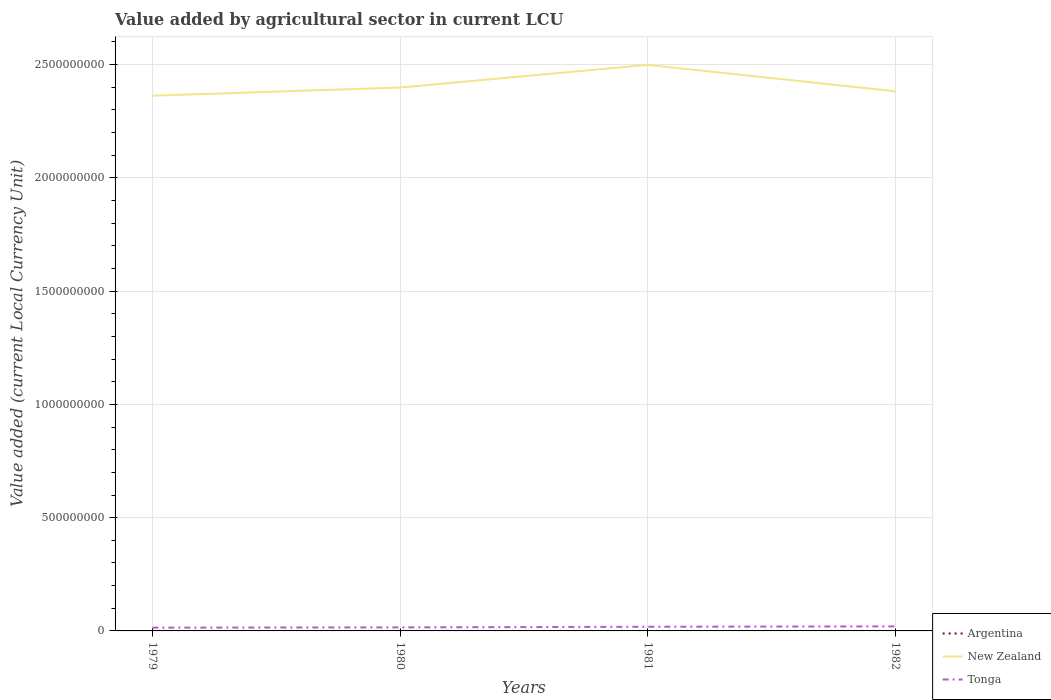How many different coloured lines are there?
Ensure brevity in your answer.  3. Does the line corresponding to Tonga intersect with the line corresponding to New Zealand?
Your answer should be very brief. No. Is the number of lines equal to the number of legend labels?
Offer a terse response. Yes. Across all years, what is the maximum value added by agricultural sector in New Zealand?
Offer a very short reply. 2.36e+09. In which year was the value added by agricultural sector in New Zealand maximum?
Give a very brief answer. 1979. What is the total value added by agricultural sector in New Zealand in the graph?
Offer a terse response. -1.00e+08. What is the difference between the highest and the second highest value added by agricultural sector in Argentina?
Give a very brief answer. 1946.37. What is the difference between the highest and the lowest value added by agricultural sector in Tonga?
Offer a very short reply. 2. How many lines are there?
Ensure brevity in your answer.  3. What is the difference between two consecutive major ticks on the Y-axis?
Ensure brevity in your answer.  5.00e+08. Are the values on the major ticks of Y-axis written in scientific E-notation?
Give a very brief answer. No. How many legend labels are there?
Ensure brevity in your answer.  3. How are the legend labels stacked?
Your answer should be compact. Vertical. What is the title of the graph?
Your response must be concise. Value added by agricultural sector in current LCU. What is the label or title of the X-axis?
Your answer should be very brief. Years. What is the label or title of the Y-axis?
Keep it short and to the point. Value added (current Local Currency Unit). What is the Value added (current Local Currency Unit) of Argentina in 1979?
Offer a very short reply. 150.63. What is the Value added (current Local Currency Unit) in New Zealand in 1979?
Make the answer very short. 2.36e+09. What is the Value added (current Local Currency Unit) of Tonga in 1979?
Keep it short and to the point. 1.45e+07. What is the Value added (current Local Currency Unit) of Argentina in 1980?
Your response must be concise. 244. What is the Value added (current Local Currency Unit) of New Zealand in 1980?
Make the answer very short. 2.40e+09. What is the Value added (current Local Currency Unit) in Tonga in 1980?
Give a very brief answer. 1.56e+07. What is the Value added (current Local Currency Unit) of Argentina in 1981?
Provide a short and direct response. 484. What is the Value added (current Local Currency Unit) in New Zealand in 1981?
Make the answer very short. 2.50e+09. What is the Value added (current Local Currency Unit) of Tonga in 1981?
Keep it short and to the point. 1.83e+07. What is the Value added (current Local Currency Unit) in Argentina in 1982?
Make the answer very short. 2097. What is the Value added (current Local Currency Unit) in New Zealand in 1982?
Provide a succinct answer. 2.38e+09. What is the Value added (current Local Currency Unit) in Tonga in 1982?
Provide a succinct answer. 2.00e+07. Across all years, what is the maximum Value added (current Local Currency Unit) in Argentina?
Your response must be concise. 2097. Across all years, what is the maximum Value added (current Local Currency Unit) in New Zealand?
Your answer should be very brief. 2.50e+09. Across all years, what is the maximum Value added (current Local Currency Unit) of Tonga?
Your answer should be very brief. 2.00e+07. Across all years, what is the minimum Value added (current Local Currency Unit) of Argentina?
Provide a succinct answer. 150.63. Across all years, what is the minimum Value added (current Local Currency Unit) of New Zealand?
Ensure brevity in your answer.  2.36e+09. Across all years, what is the minimum Value added (current Local Currency Unit) in Tonga?
Provide a succinct answer. 1.45e+07. What is the total Value added (current Local Currency Unit) in Argentina in the graph?
Your response must be concise. 2975.64. What is the total Value added (current Local Currency Unit) of New Zealand in the graph?
Offer a very short reply. 9.64e+09. What is the total Value added (current Local Currency Unit) of Tonga in the graph?
Offer a terse response. 6.85e+07. What is the difference between the Value added (current Local Currency Unit) of Argentina in 1979 and that in 1980?
Provide a short and direct response. -93.36. What is the difference between the Value added (current Local Currency Unit) in New Zealand in 1979 and that in 1980?
Offer a very short reply. -3.60e+07. What is the difference between the Value added (current Local Currency Unit) of Tonga in 1979 and that in 1980?
Keep it short and to the point. -1.15e+06. What is the difference between the Value added (current Local Currency Unit) in Argentina in 1979 and that in 1981?
Ensure brevity in your answer.  -333.37. What is the difference between the Value added (current Local Currency Unit) in New Zealand in 1979 and that in 1981?
Your response must be concise. -1.36e+08. What is the difference between the Value added (current Local Currency Unit) in Tonga in 1979 and that in 1981?
Ensure brevity in your answer.  -3.84e+06. What is the difference between the Value added (current Local Currency Unit) in Argentina in 1979 and that in 1982?
Offer a terse response. -1946.37. What is the difference between the Value added (current Local Currency Unit) of New Zealand in 1979 and that in 1982?
Offer a very short reply. -1.92e+07. What is the difference between the Value added (current Local Currency Unit) of Tonga in 1979 and that in 1982?
Your answer should be very brief. -5.55e+06. What is the difference between the Value added (current Local Currency Unit) of Argentina in 1980 and that in 1981?
Your answer should be very brief. -240. What is the difference between the Value added (current Local Currency Unit) of New Zealand in 1980 and that in 1981?
Make the answer very short. -1.00e+08. What is the difference between the Value added (current Local Currency Unit) of Tonga in 1980 and that in 1981?
Offer a terse response. -2.69e+06. What is the difference between the Value added (current Local Currency Unit) in Argentina in 1980 and that in 1982?
Give a very brief answer. -1853. What is the difference between the Value added (current Local Currency Unit) of New Zealand in 1980 and that in 1982?
Provide a succinct answer. 1.67e+07. What is the difference between the Value added (current Local Currency Unit) in Tonga in 1980 and that in 1982?
Your response must be concise. -4.41e+06. What is the difference between the Value added (current Local Currency Unit) in Argentina in 1981 and that in 1982?
Offer a terse response. -1613. What is the difference between the Value added (current Local Currency Unit) in New Zealand in 1981 and that in 1982?
Give a very brief answer. 1.17e+08. What is the difference between the Value added (current Local Currency Unit) of Tonga in 1981 and that in 1982?
Provide a short and direct response. -1.72e+06. What is the difference between the Value added (current Local Currency Unit) in Argentina in 1979 and the Value added (current Local Currency Unit) in New Zealand in 1980?
Your response must be concise. -2.40e+09. What is the difference between the Value added (current Local Currency Unit) in Argentina in 1979 and the Value added (current Local Currency Unit) in Tonga in 1980?
Offer a very short reply. -1.56e+07. What is the difference between the Value added (current Local Currency Unit) in New Zealand in 1979 and the Value added (current Local Currency Unit) in Tonga in 1980?
Offer a very short reply. 2.35e+09. What is the difference between the Value added (current Local Currency Unit) of Argentina in 1979 and the Value added (current Local Currency Unit) of New Zealand in 1981?
Your answer should be very brief. -2.50e+09. What is the difference between the Value added (current Local Currency Unit) in Argentina in 1979 and the Value added (current Local Currency Unit) in Tonga in 1981?
Provide a short and direct response. -1.83e+07. What is the difference between the Value added (current Local Currency Unit) in New Zealand in 1979 and the Value added (current Local Currency Unit) in Tonga in 1981?
Your answer should be compact. 2.34e+09. What is the difference between the Value added (current Local Currency Unit) of Argentina in 1979 and the Value added (current Local Currency Unit) of New Zealand in 1982?
Your answer should be very brief. -2.38e+09. What is the difference between the Value added (current Local Currency Unit) of Argentina in 1979 and the Value added (current Local Currency Unit) of Tonga in 1982?
Offer a very short reply. -2.00e+07. What is the difference between the Value added (current Local Currency Unit) in New Zealand in 1979 and the Value added (current Local Currency Unit) in Tonga in 1982?
Ensure brevity in your answer.  2.34e+09. What is the difference between the Value added (current Local Currency Unit) of Argentina in 1980 and the Value added (current Local Currency Unit) of New Zealand in 1981?
Provide a succinct answer. -2.50e+09. What is the difference between the Value added (current Local Currency Unit) of Argentina in 1980 and the Value added (current Local Currency Unit) of Tonga in 1981?
Give a very brief answer. -1.83e+07. What is the difference between the Value added (current Local Currency Unit) of New Zealand in 1980 and the Value added (current Local Currency Unit) of Tonga in 1981?
Provide a short and direct response. 2.38e+09. What is the difference between the Value added (current Local Currency Unit) in Argentina in 1980 and the Value added (current Local Currency Unit) in New Zealand in 1982?
Offer a terse response. -2.38e+09. What is the difference between the Value added (current Local Currency Unit) of Argentina in 1980 and the Value added (current Local Currency Unit) of Tonga in 1982?
Give a very brief answer. -2.00e+07. What is the difference between the Value added (current Local Currency Unit) in New Zealand in 1980 and the Value added (current Local Currency Unit) in Tonga in 1982?
Provide a succinct answer. 2.38e+09. What is the difference between the Value added (current Local Currency Unit) of Argentina in 1981 and the Value added (current Local Currency Unit) of New Zealand in 1982?
Give a very brief answer. -2.38e+09. What is the difference between the Value added (current Local Currency Unit) of Argentina in 1981 and the Value added (current Local Currency Unit) of Tonga in 1982?
Your answer should be compact. -2.00e+07. What is the difference between the Value added (current Local Currency Unit) in New Zealand in 1981 and the Value added (current Local Currency Unit) in Tonga in 1982?
Your answer should be very brief. 2.48e+09. What is the average Value added (current Local Currency Unit) in Argentina per year?
Offer a very short reply. 743.91. What is the average Value added (current Local Currency Unit) in New Zealand per year?
Provide a short and direct response. 2.41e+09. What is the average Value added (current Local Currency Unit) of Tonga per year?
Your response must be concise. 1.71e+07. In the year 1979, what is the difference between the Value added (current Local Currency Unit) of Argentina and Value added (current Local Currency Unit) of New Zealand?
Give a very brief answer. -2.36e+09. In the year 1979, what is the difference between the Value added (current Local Currency Unit) in Argentina and Value added (current Local Currency Unit) in Tonga?
Ensure brevity in your answer.  -1.45e+07. In the year 1979, what is the difference between the Value added (current Local Currency Unit) in New Zealand and Value added (current Local Currency Unit) in Tonga?
Keep it short and to the point. 2.35e+09. In the year 1980, what is the difference between the Value added (current Local Currency Unit) of Argentina and Value added (current Local Currency Unit) of New Zealand?
Your answer should be compact. -2.40e+09. In the year 1980, what is the difference between the Value added (current Local Currency Unit) of Argentina and Value added (current Local Currency Unit) of Tonga?
Keep it short and to the point. -1.56e+07. In the year 1980, what is the difference between the Value added (current Local Currency Unit) of New Zealand and Value added (current Local Currency Unit) of Tonga?
Offer a terse response. 2.38e+09. In the year 1981, what is the difference between the Value added (current Local Currency Unit) of Argentina and Value added (current Local Currency Unit) of New Zealand?
Your response must be concise. -2.50e+09. In the year 1981, what is the difference between the Value added (current Local Currency Unit) in Argentina and Value added (current Local Currency Unit) in Tonga?
Your answer should be compact. -1.83e+07. In the year 1981, what is the difference between the Value added (current Local Currency Unit) of New Zealand and Value added (current Local Currency Unit) of Tonga?
Make the answer very short. 2.48e+09. In the year 1982, what is the difference between the Value added (current Local Currency Unit) in Argentina and Value added (current Local Currency Unit) in New Zealand?
Offer a terse response. -2.38e+09. In the year 1982, what is the difference between the Value added (current Local Currency Unit) of Argentina and Value added (current Local Currency Unit) of Tonga?
Make the answer very short. -2.00e+07. In the year 1982, what is the difference between the Value added (current Local Currency Unit) in New Zealand and Value added (current Local Currency Unit) in Tonga?
Ensure brevity in your answer.  2.36e+09. What is the ratio of the Value added (current Local Currency Unit) of Argentina in 1979 to that in 1980?
Keep it short and to the point. 0.62. What is the ratio of the Value added (current Local Currency Unit) in New Zealand in 1979 to that in 1980?
Your response must be concise. 0.98. What is the ratio of the Value added (current Local Currency Unit) of Tonga in 1979 to that in 1980?
Make the answer very short. 0.93. What is the ratio of the Value added (current Local Currency Unit) in Argentina in 1979 to that in 1981?
Your answer should be very brief. 0.31. What is the ratio of the Value added (current Local Currency Unit) of New Zealand in 1979 to that in 1981?
Ensure brevity in your answer.  0.95. What is the ratio of the Value added (current Local Currency Unit) of Tonga in 1979 to that in 1981?
Keep it short and to the point. 0.79. What is the ratio of the Value added (current Local Currency Unit) in Argentina in 1979 to that in 1982?
Ensure brevity in your answer.  0.07. What is the ratio of the Value added (current Local Currency Unit) in New Zealand in 1979 to that in 1982?
Give a very brief answer. 0.99. What is the ratio of the Value added (current Local Currency Unit) of Tonga in 1979 to that in 1982?
Your answer should be compact. 0.72. What is the ratio of the Value added (current Local Currency Unit) of Argentina in 1980 to that in 1981?
Make the answer very short. 0.5. What is the ratio of the Value added (current Local Currency Unit) of New Zealand in 1980 to that in 1981?
Your answer should be compact. 0.96. What is the ratio of the Value added (current Local Currency Unit) in Tonga in 1980 to that in 1981?
Ensure brevity in your answer.  0.85. What is the ratio of the Value added (current Local Currency Unit) in Argentina in 1980 to that in 1982?
Ensure brevity in your answer.  0.12. What is the ratio of the Value added (current Local Currency Unit) of Tonga in 1980 to that in 1982?
Your response must be concise. 0.78. What is the ratio of the Value added (current Local Currency Unit) in Argentina in 1981 to that in 1982?
Ensure brevity in your answer.  0.23. What is the ratio of the Value added (current Local Currency Unit) of New Zealand in 1981 to that in 1982?
Your response must be concise. 1.05. What is the ratio of the Value added (current Local Currency Unit) of Tonga in 1981 to that in 1982?
Provide a succinct answer. 0.91. What is the difference between the highest and the second highest Value added (current Local Currency Unit) in Argentina?
Give a very brief answer. 1613. What is the difference between the highest and the second highest Value added (current Local Currency Unit) in New Zealand?
Ensure brevity in your answer.  1.00e+08. What is the difference between the highest and the second highest Value added (current Local Currency Unit) in Tonga?
Offer a terse response. 1.72e+06. What is the difference between the highest and the lowest Value added (current Local Currency Unit) in Argentina?
Offer a terse response. 1946.37. What is the difference between the highest and the lowest Value added (current Local Currency Unit) in New Zealand?
Provide a succinct answer. 1.36e+08. What is the difference between the highest and the lowest Value added (current Local Currency Unit) in Tonga?
Provide a succinct answer. 5.55e+06. 